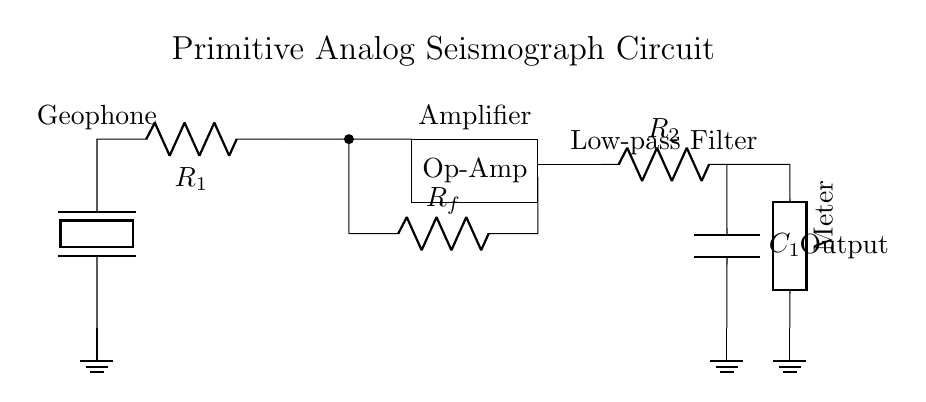What component is used as a ground sensor in the circuit? The component used as a ground sensor in the circuit is the piezoelectric element, also known as the geophone, which detects vibrations in the ground.
Answer: piezoelectric What is the purpose of the op-amp in this circuit? The op-amp amplifies the signal received from the geophone, making it easier to measure ground vibrations. The amplified signal is necessary for accurate readings.
Answer: amplification What type of filter is implemented in this circuit? The circuit contains a low-pass filter, which is designed to allow low-frequency signals (like vibrations) to pass while attenuating higher-frequency noise.
Answer: low-pass filter How many resistors are present in the circuit? There are two resistors in the circuit, namely R1 and Rf, as indicated in the diagram.
Answer: two What is the output measurement device in the circuit? The output stage of the circuit includes a meter, which is used to display the amplified signal resulting from the vibrations detected by the geophone.
Answer: meter Why is a low-pass filter important in this seismograph circuit? A low-pass filter is important because it helps to eliminate high-frequency noise, ensuring that only the relevant low-frequency vibrations are captured and measured accurately. This is crucial for detecting ground motion during ceremonies or dances.
Answer: to eliminate high-frequency noise 